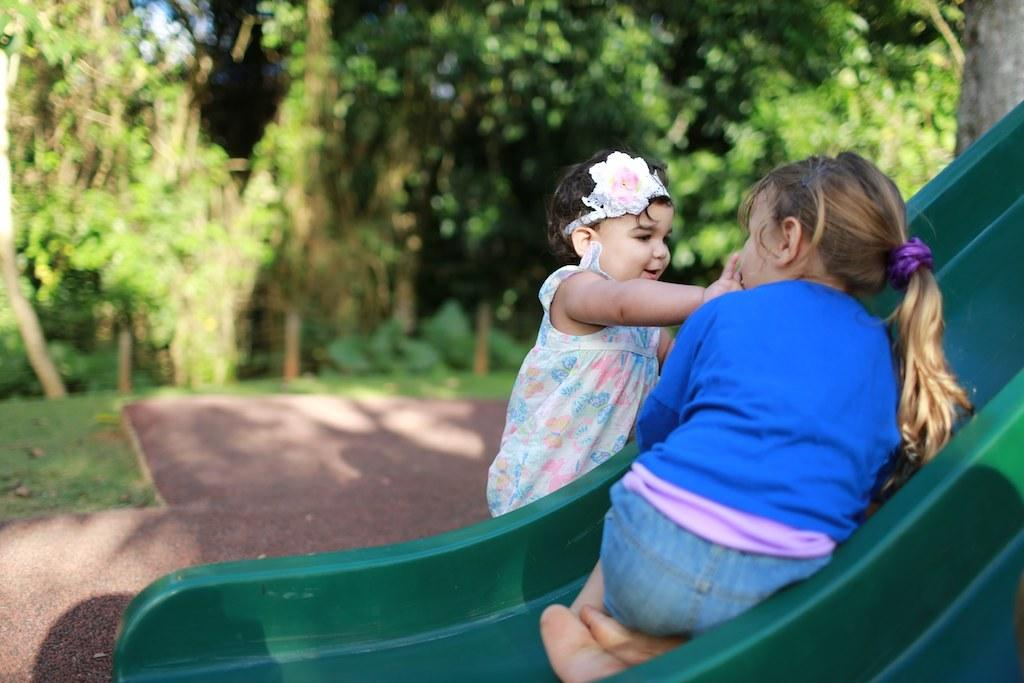How many girls are present in the image? There are two girls in the image. What is one of the girls doing in the image? One of the girls is sitting on a slide. What can be seen in the background of the image? There are trees visible in the background of the image. What type of attraction is the mom taking the girls to in the image? There is no mom or attraction present in the image; it only features two girls and a slide. 